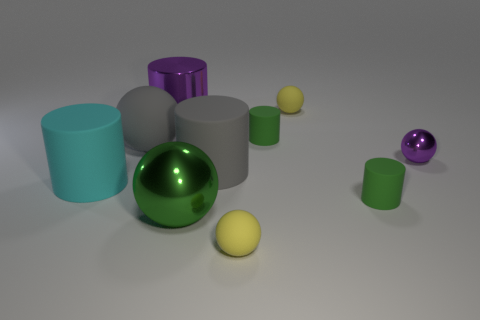How many tiny cylinders are there?
Offer a very short reply. 2. Do the purple cylinder and the purple shiny sphere have the same size?
Ensure brevity in your answer.  No. Is there another big cylinder of the same color as the large metallic cylinder?
Offer a very short reply. No. There is a green matte object behind the large cyan rubber cylinder; is it the same shape as the large cyan thing?
Your answer should be compact. Yes. What number of green matte objects have the same size as the purple metal sphere?
Your response must be concise. 2. There is a purple object that is behind the tiny shiny object; how many metallic objects are in front of it?
Give a very brief answer. 2. Is the thing that is behind the shiny cylinder made of the same material as the large cyan cylinder?
Ensure brevity in your answer.  Yes. Do the yellow ball in front of the large gray cylinder and the yellow sphere behind the cyan rubber cylinder have the same material?
Offer a very short reply. Yes. Are there more big shiny balls that are left of the gray rubber cylinder than brown metal things?
Offer a very short reply. Yes. The small ball that is behind the purple shiny cylinder behind the tiny shiny sphere is what color?
Offer a very short reply. Yellow. 